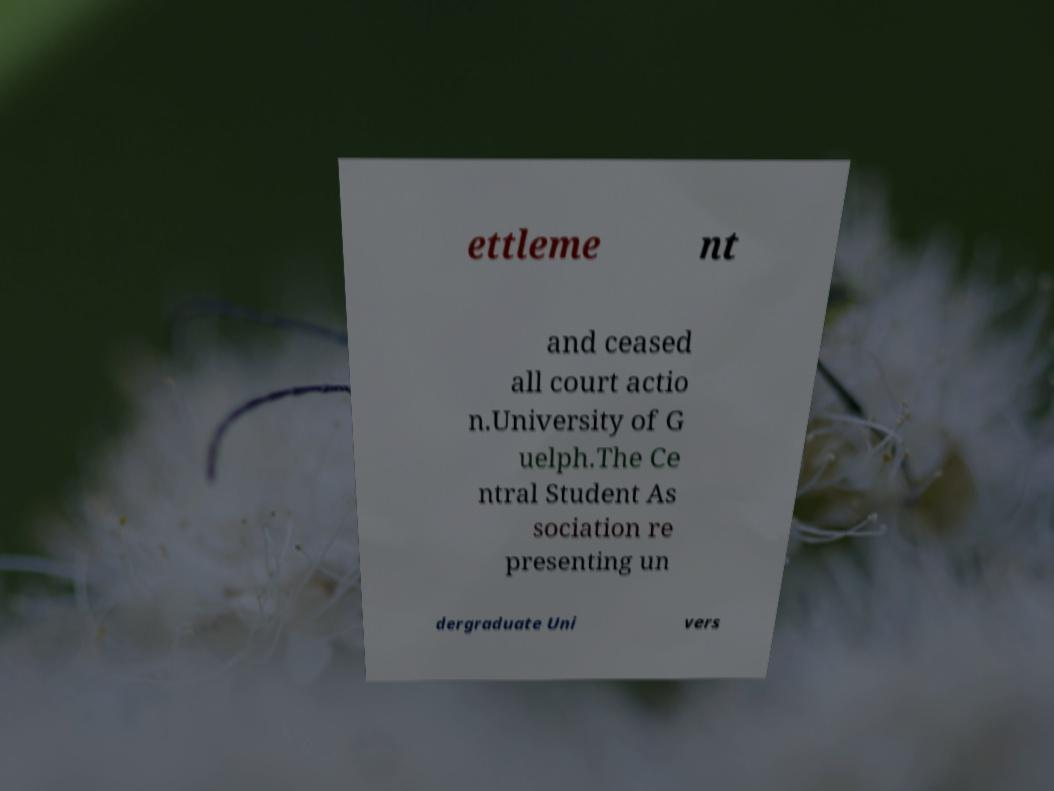Can you accurately transcribe the text from the provided image for me? ettleme nt and ceased all court actio n.University of G uelph.The Ce ntral Student As sociation re presenting un dergraduate Uni vers 